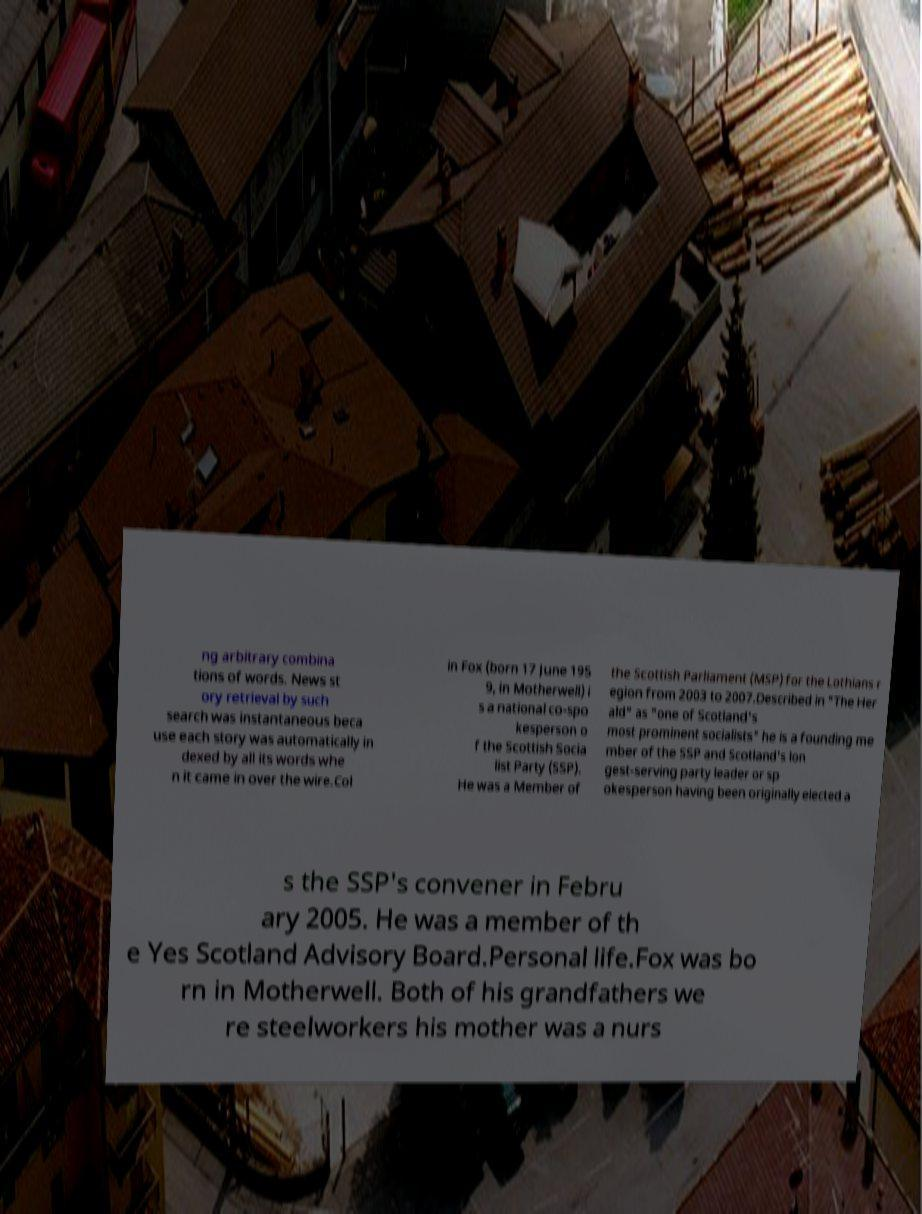There's text embedded in this image that I need extracted. Can you transcribe it verbatim? ng arbitrary combina tions of words. News st ory retrieval by such search was instantaneous beca use each story was automatically in dexed by all its words whe n it came in over the wire.Col in Fox (born 17 June 195 9, in Motherwell) i s a national co-spo kesperson o f the Scottish Socia list Party (SSP). He was a Member of the Scottish Parliament (MSP) for the Lothians r egion from 2003 to 2007.Described in "The Her ald" as "one of Scotland's most prominent socialists" he is a founding me mber of the SSP and Scotland's lon gest-serving party leader or sp okesperson having been originally elected a s the SSP's convener in Febru ary 2005. He was a member of th e Yes Scotland Advisory Board.Personal life.Fox was bo rn in Motherwell. Both of his grandfathers we re steelworkers his mother was a nurs 